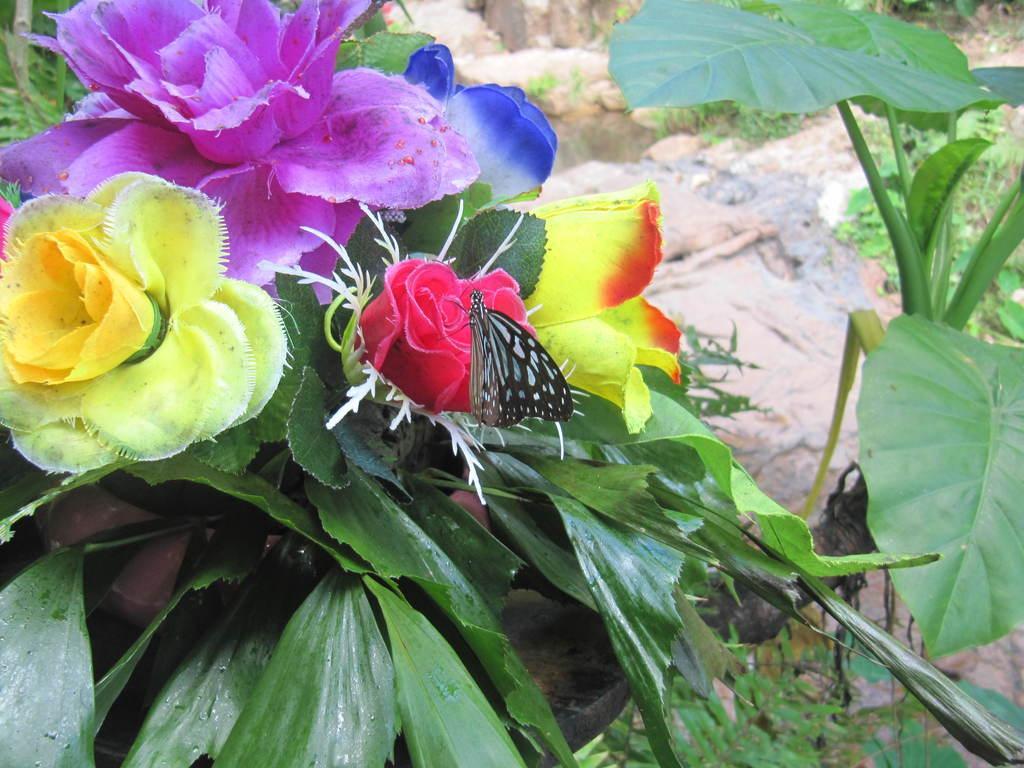How would you summarize this image in a sentence or two? In this image, I can see a butterfly on a flower. This looks like a plant with the colorful flowers. These are the leaves, which are green in color. In the background, these look like the rocks. 